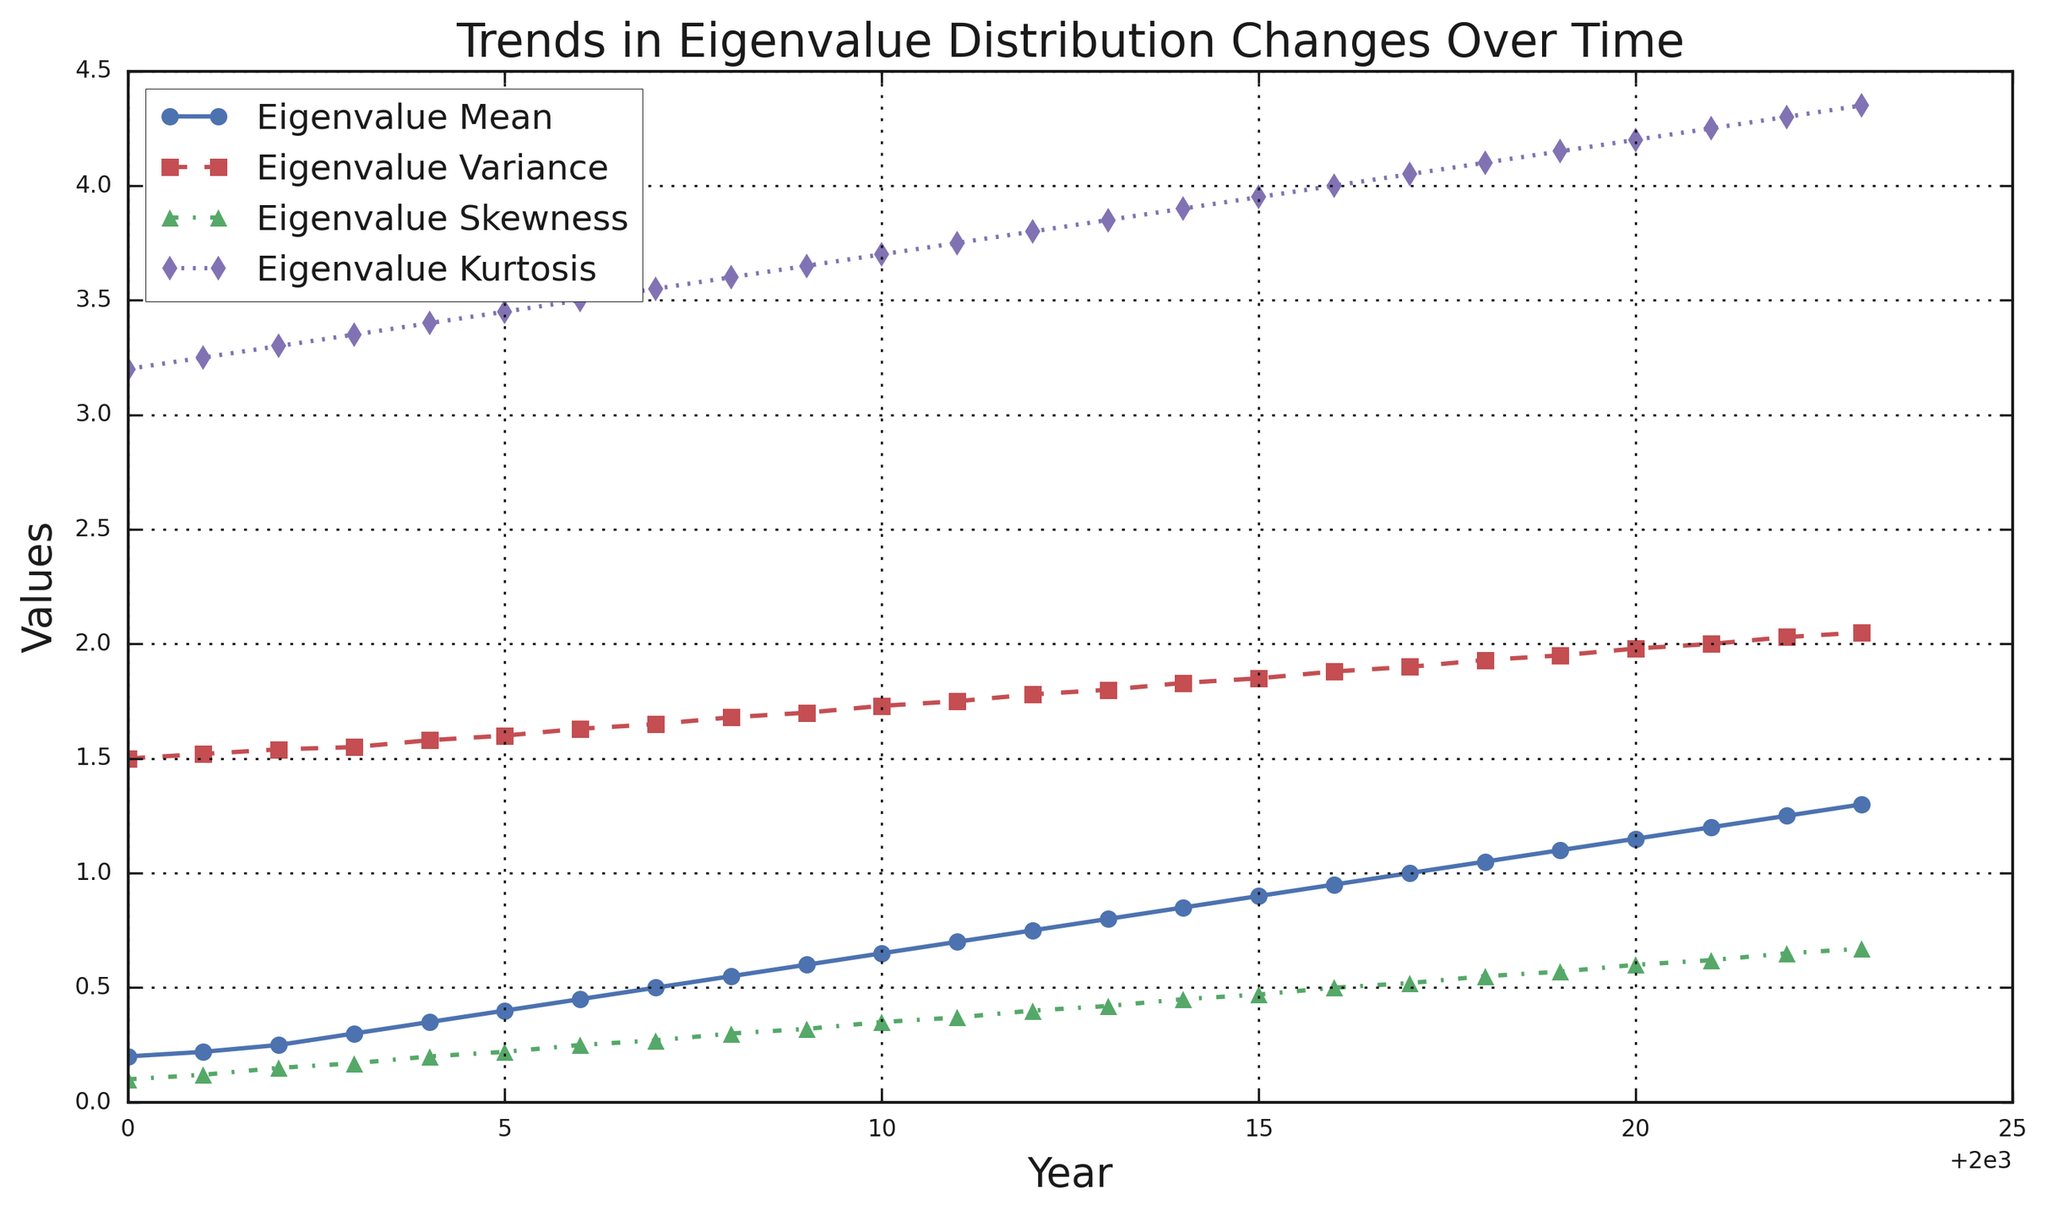What is the general trend of the Eigenvalue Mean from 2000 to 2023? To answer this, observe the blue line in the plot representing the Eigenvalue Mean. Notice that it starts at 0.2 in 2000 and steadily increases to 1.3 by 2023. This indicates a consistent upward trend.
Answer: Increasing Which year shows the largest increase in Eigenvalue Kurtosis? Examine the magenta line representing Eigenvalue Kurtosis. Look for the steepest upward slope. Between 2020 (4.2) and 2021 (4.25), the increase is 0.05, which is the largest increase.
Answer: 2020 to 2021 What is the difference between the Eigenvalue Mean and Eigenvalue Variance in 2023? In 2023, Eigenvalue Mean is 1.3 and Eigenvalue Variance is 2.05. Subtract 1.3 from 2.05 to get the difference: 2.05 - 1.3 = 0.75.
Answer: 0.75 Which visual element represents Eigenvalue Skewness, and what is one characteristic of its trend? The green line with triangle markers represents Eigenvalue Skewness. One characteristic of its trend is that it consistently rises from 0.1 in 2000 to 0.67 in 2023 without any decreases.
Answer: Green line with triangles; consistently rising How does the trend in Eigenvalue Variance compare to that in Eigenvalue Mean over the years? Compare the red dashed line (Eigenvalue Variance) and blue solid line (Eigenvalue Mean). Both show an upward trend, but the Eigenvalue Variance increases at a slower rate than the Eigenvalue Mean.
Answer: Similar upward trend; Mean increases more rapidly What is the average increase per year in Eigenvalue Kurtosis from 2000 to 2023? Eigenvalue Kurtosis starts at 3.2 in 2000 and reaches 4.35 in 2023. There are 23 years between these two points. Calculate the total increase: 4.35 - 3.2 = 1.15. Then, find the average increase per year: 1.15 / 23 ≈ 0.05.
Answer: 0.05 During which years are all four metrics increasing simultaneously? Check the plot closely to find a period when all four lines are trending upward. From 2000 to 2023, all four metrics show a consistent increase in every year.
Answer: 2000 to 2023 Which metric shows the smallest increase in absolute terms from 2000 to 2023? Calculate the increase for each metric by subtracting their values in 2000 from their values in 2023. Eigenvalue Mean: 1.3-0.2 = 1.1, Eigenvalue Variance: 2.05-1.5 = 0.55, Eigenvalue Skewness: 0.67-0.1 = 0.57, Eigenvalue Kurtosis: 4.35-3.2 = 1.15. Eigenvalue Variance has the smallest increase (0.55).
Answer: Eigenvalue Variance In what year is the Eigenvalue Mean exactly half of the Eigenvalue Variance? Look for the year when the Eigenvalue Mean is exactly half the Eigenvalue Variance. From the plot, in 2011, the Eigenvalue Mean (0.7) is exactly half of the Eigenvalue Variance (1.75).
Answer: 2011 